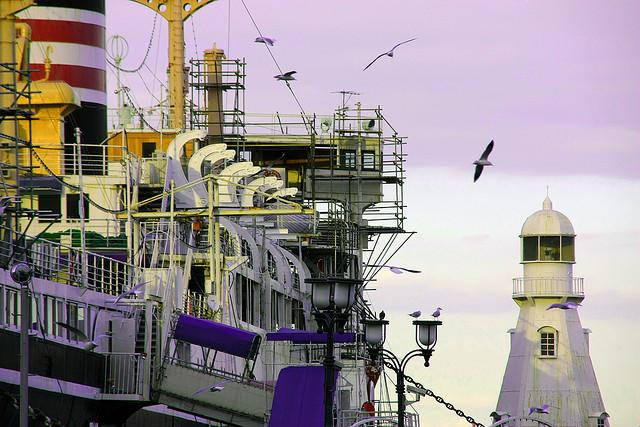How many kind of ships available mostly?

Choices:
A) three
B) two
C) seven
D) four seven 